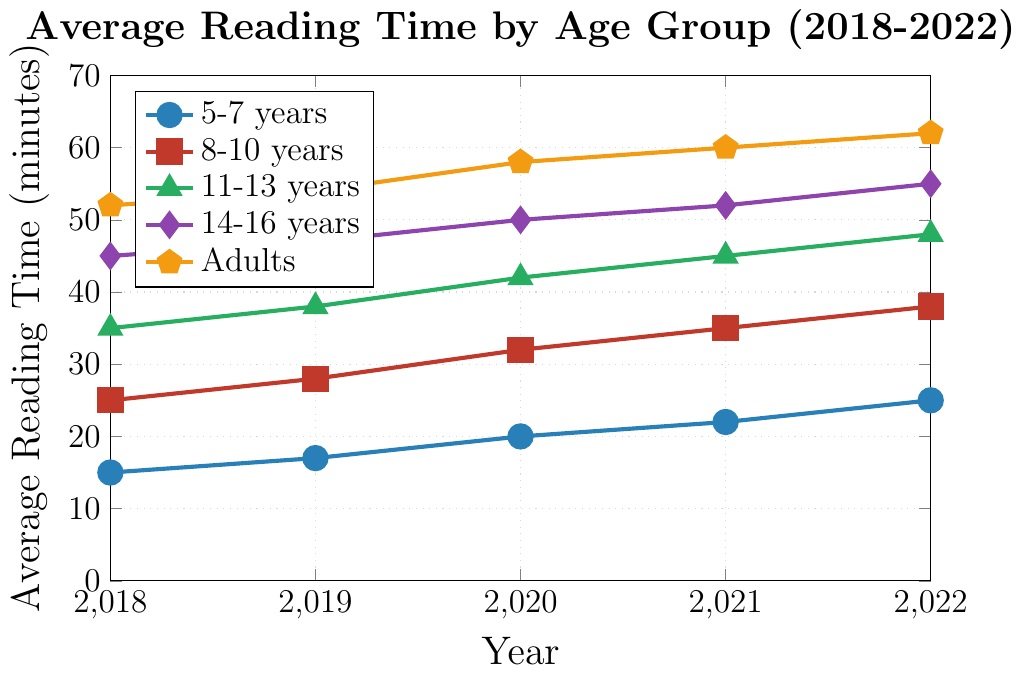How did the average reading time for 5-7 years change from 2018 to 2022? To determine the change, subtract the value in 2018 from the value in 2022. The average reading time in 2018 is 15 minutes, and in 2022 it is 25 minutes. So, 25 - 15 = 10 minutes.
Answer: Increased by 10 minutes Between which years did the average reading time for the 14-16 years group see the most significant increase? Calculate the yearly differences: 2019-2018 is 47-45=2, 2020-2019 is 50-47=3, 2021-2020 is 52-50=2, 2022-2021 is 55-52=3. The most significant increase of 3 minutes occurred between 2019-2020 and 2021-2022.
Answer: 2020 and 2021; 2022 and 2023 Which age group had the highest average reading time in 2022? Compare the 2022 values for all age groups: 5-7 years is 25, 8-10 years is 38, 11-13 years is 48, 14-16 years is 55, and Adults is 62. The highest value is 62 minutes.
Answer: Adults What is the average reading time for the 8-10 years group over the 5-year period? Sum the values for 2018 to 2022 for the 8-10 years group: 25 + 28 + 32 + 35 + 38 = 158. Divide by 5 to get the average: 158/5 = 31.6 minutes.
Answer: 31.6 minutes How does the increase in average reading time from 2019 to 2022 compare between 11-13 years and 14-16 years age groups? Calculate each group's increase from 2019 to 2022: For 11-13 years: (48-38) = 10 minutes. For 14-16 years: (55-47) = 8 minutes. Compare both values.
Answer: 11-13 years group increased by 2 minutes more Which age group's reading time saw the smallest increase over the entire period? Calculate the total increase from 2018 to 2022 for each group: 5-7 years: 25-15=10, 8-10 years: 38-25=13, 11-13 years: 48-35=13, 14-16 years: 55-45=10, Adults: 62-52=10. The 5-7 years, 14-16 years, and Adults groups had the smallest increase of 10 minutes.
Answer: 5-7 years, 14-16 years, Adults What trend can we observe in the average reading times for the 8-10 years age group? The trend can be seen by looking at the values for 8-10 years: 25 (2018), 28 (2019), 32 (2020), 35 (2021), and 38 (2022). The values consistently increase each year.
Answer: Consistent increase Compare the average reading times of 5-7 years and 11-13 years in 2020. Look at the values for 2020 for both age groups: 5-7 years is 20, and 11-13 years is 42. The 11-13 years group's time is more than double that of the 5-7 years group.
Answer: 11-13 years group is 22 minutes more Considering Adults have the highest average reading time in 2022, by how many minutes does it exceed the reading time of 14-16 years in the same year? The 2022 values are 62 for Adults and 55 for 14-16 years. Calculate the difference: 62 - 55 = 7 minutes.
Answer: 7 minutes 